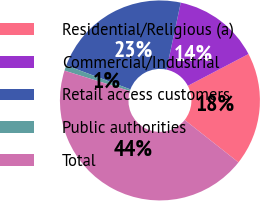Convert chart to OTSL. <chart><loc_0><loc_0><loc_500><loc_500><pie_chart><fcel>Residential/Religious (a)<fcel>Commercial/Industrial<fcel>Retail access customers<fcel>Public authorities<fcel>Total<nl><fcel>18.31%<fcel>13.98%<fcel>22.64%<fcel>0.88%<fcel>44.19%<nl></chart> 